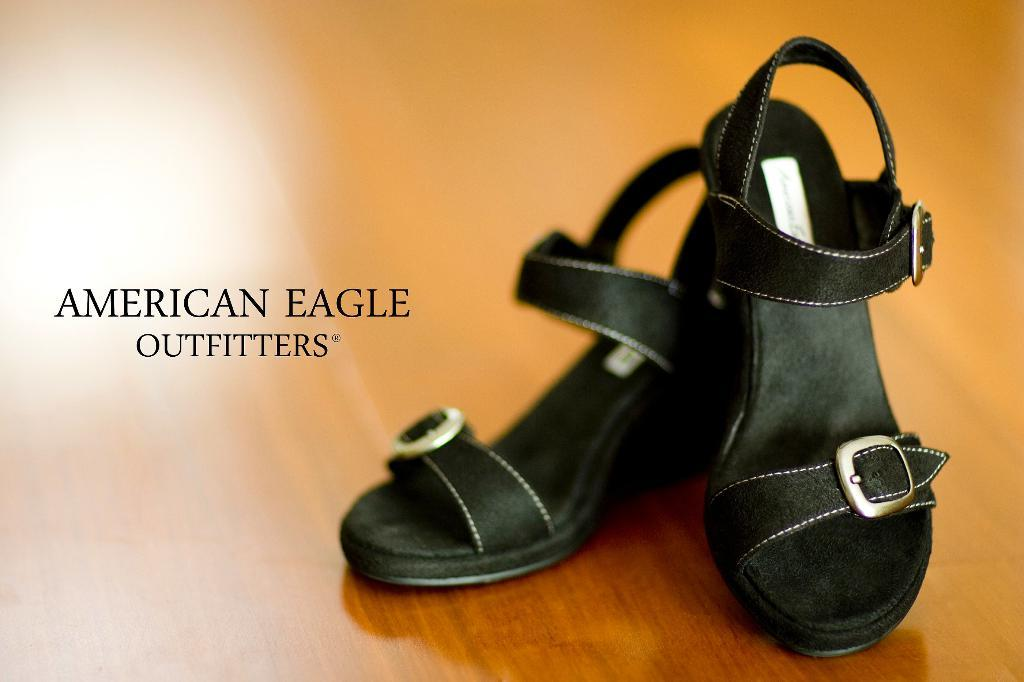What type of footwear is present in the image? There are black sandals in the image. What is the color of the surface the sandals are on? The sandals are on a brown surface. Is there any text or writing visible in the image? Yes, there is text or writing visible in the image. What time of day is it in the image, and is the frog awake? The time of day is not mentioned in the image, and there is no frog present to determine if it is awake or not. 